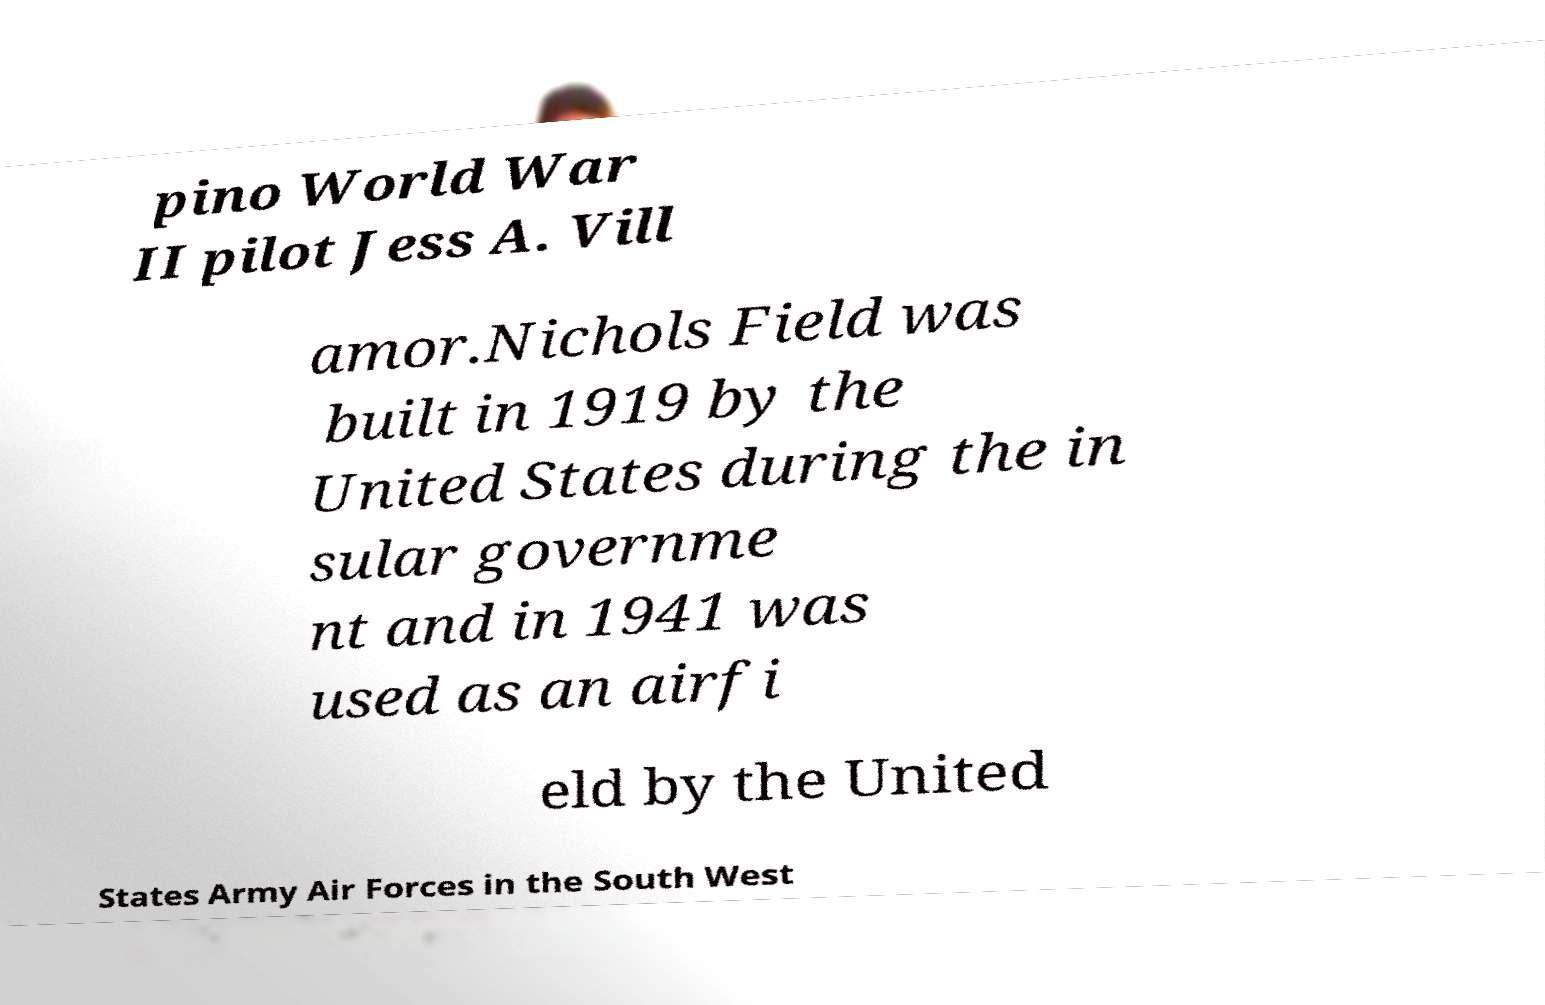There's text embedded in this image that I need extracted. Can you transcribe it verbatim? pino World War II pilot Jess A. Vill amor.Nichols Field was built in 1919 by the United States during the in sular governme nt and in 1941 was used as an airfi eld by the United States Army Air Forces in the South West 